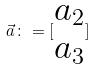Convert formula to latex. <formula><loc_0><loc_0><loc_500><loc_500>\vec { a } \colon = [ \begin{matrix} a _ { 2 } \\ a _ { 3 } \end{matrix} ]</formula> 